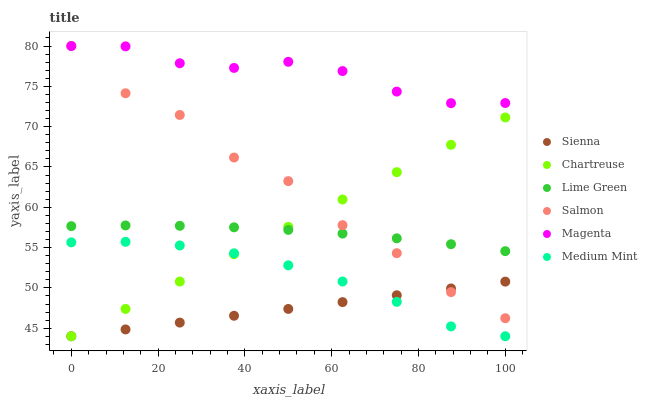Does Sienna have the minimum area under the curve?
Answer yes or no. Yes. Does Magenta have the maximum area under the curve?
Answer yes or no. Yes. Does Salmon have the minimum area under the curve?
Answer yes or no. No. Does Salmon have the maximum area under the curve?
Answer yes or no. No. Is Sienna the smoothest?
Answer yes or no. Yes. Is Salmon the roughest?
Answer yes or no. Yes. Is Salmon the smoothest?
Answer yes or no. No. Is Sienna the roughest?
Answer yes or no. No. Does Medium Mint have the lowest value?
Answer yes or no. Yes. Does Salmon have the lowest value?
Answer yes or no. No. Does Magenta have the highest value?
Answer yes or no. Yes. Does Sienna have the highest value?
Answer yes or no. No. Is Medium Mint less than Salmon?
Answer yes or no. Yes. Is Magenta greater than Lime Green?
Answer yes or no. Yes. Does Medium Mint intersect Sienna?
Answer yes or no. Yes. Is Medium Mint less than Sienna?
Answer yes or no. No. Is Medium Mint greater than Sienna?
Answer yes or no. No. Does Medium Mint intersect Salmon?
Answer yes or no. No. 